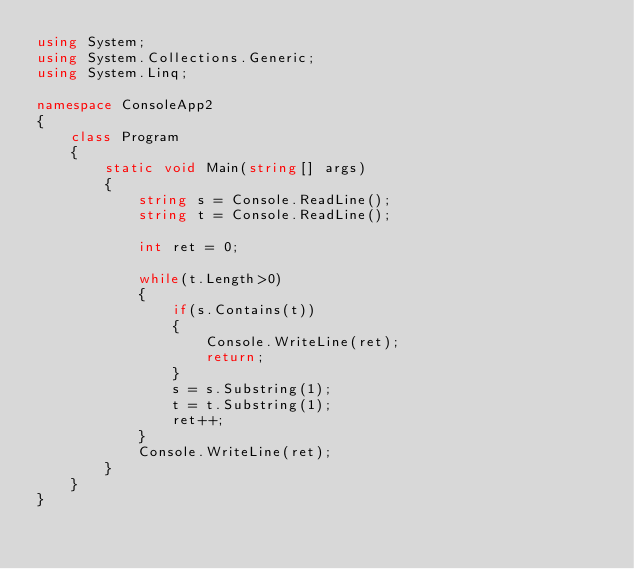Convert code to text. <code><loc_0><loc_0><loc_500><loc_500><_C#_>using System;
using System.Collections.Generic;
using System.Linq;

namespace ConsoleApp2
{
    class Program
    {
        static void Main(string[] args)
        {
            string s = Console.ReadLine();
            string t = Console.ReadLine();

            int ret = 0;

            while(t.Length>0)
            {
                if(s.Contains(t))
                {
                    Console.WriteLine(ret);
                    return;
                }
                s = s.Substring(1);
                t = t.Substring(1);
                ret++;
            }
            Console.WriteLine(ret);
        }
    }
}</code> 